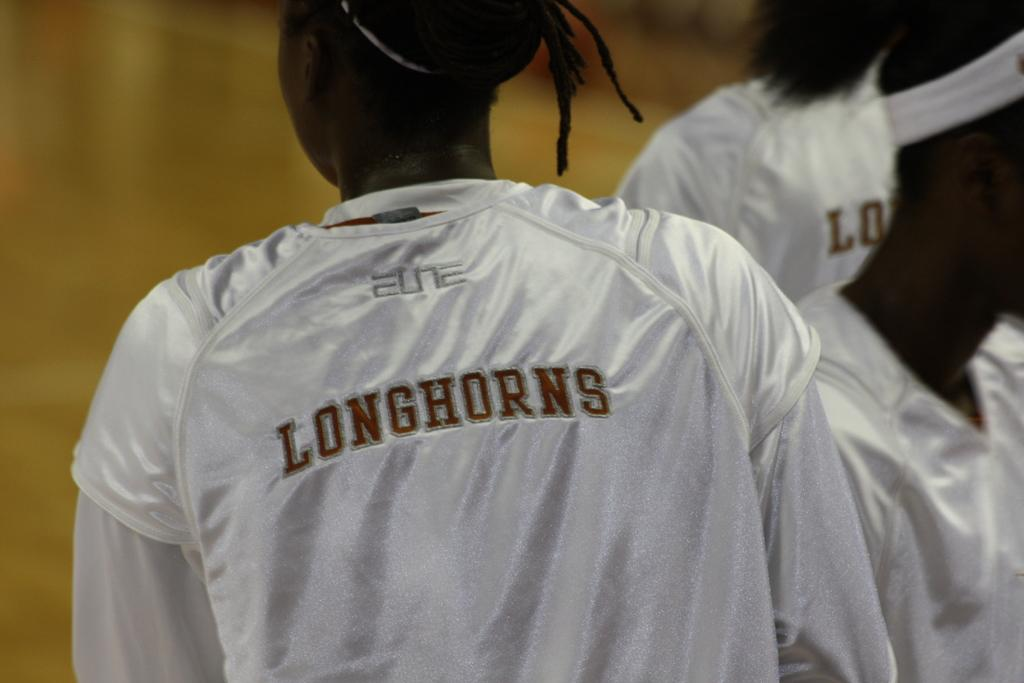<image>
Describe the image concisely. Person wearing a Longhorns jersey standing by someone else. 